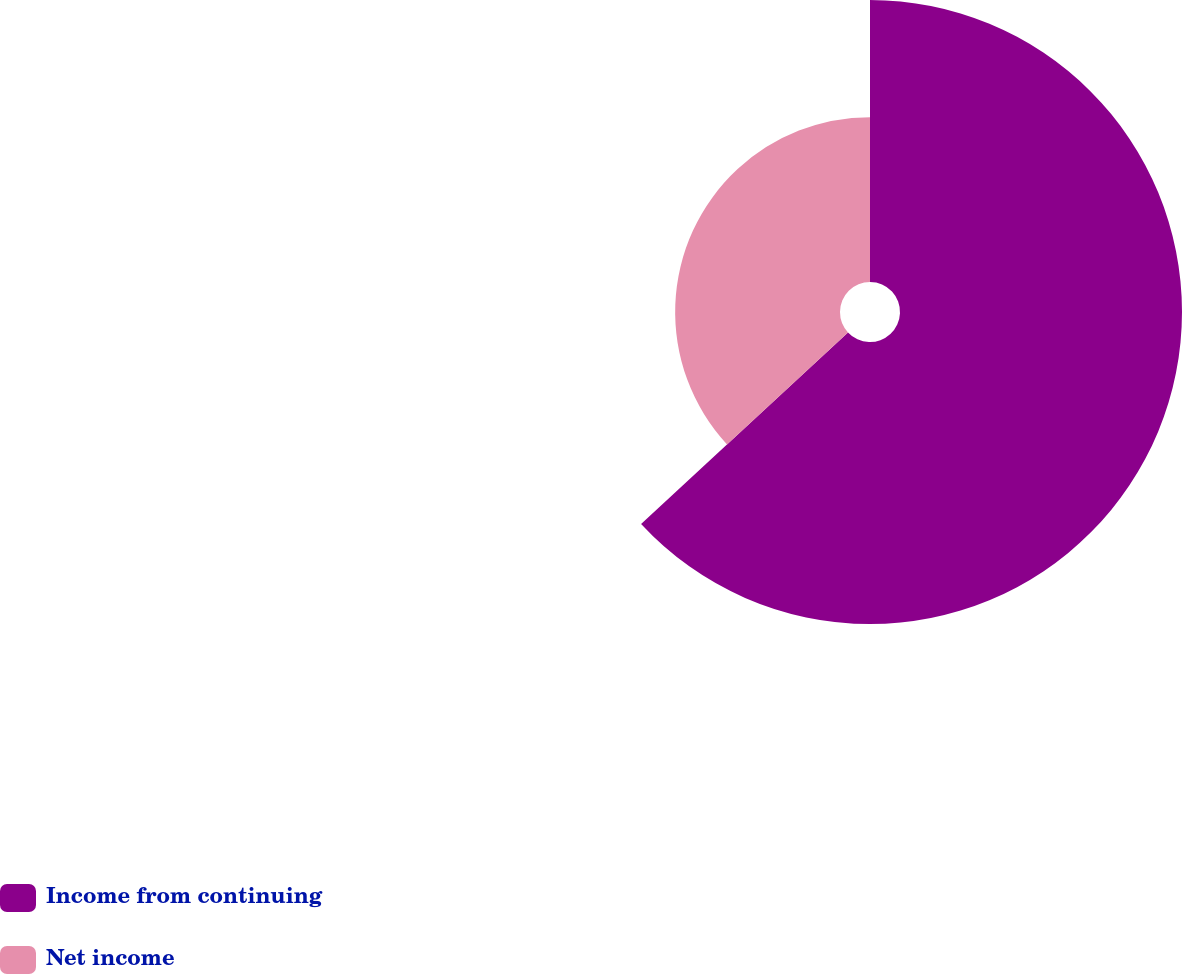<chart> <loc_0><loc_0><loc_500><loc_500><pie_chart><fcel>Income from continuing<fcel>Net income<nl><fcel>63.11%<fcel>36.89%<nl></chart> 